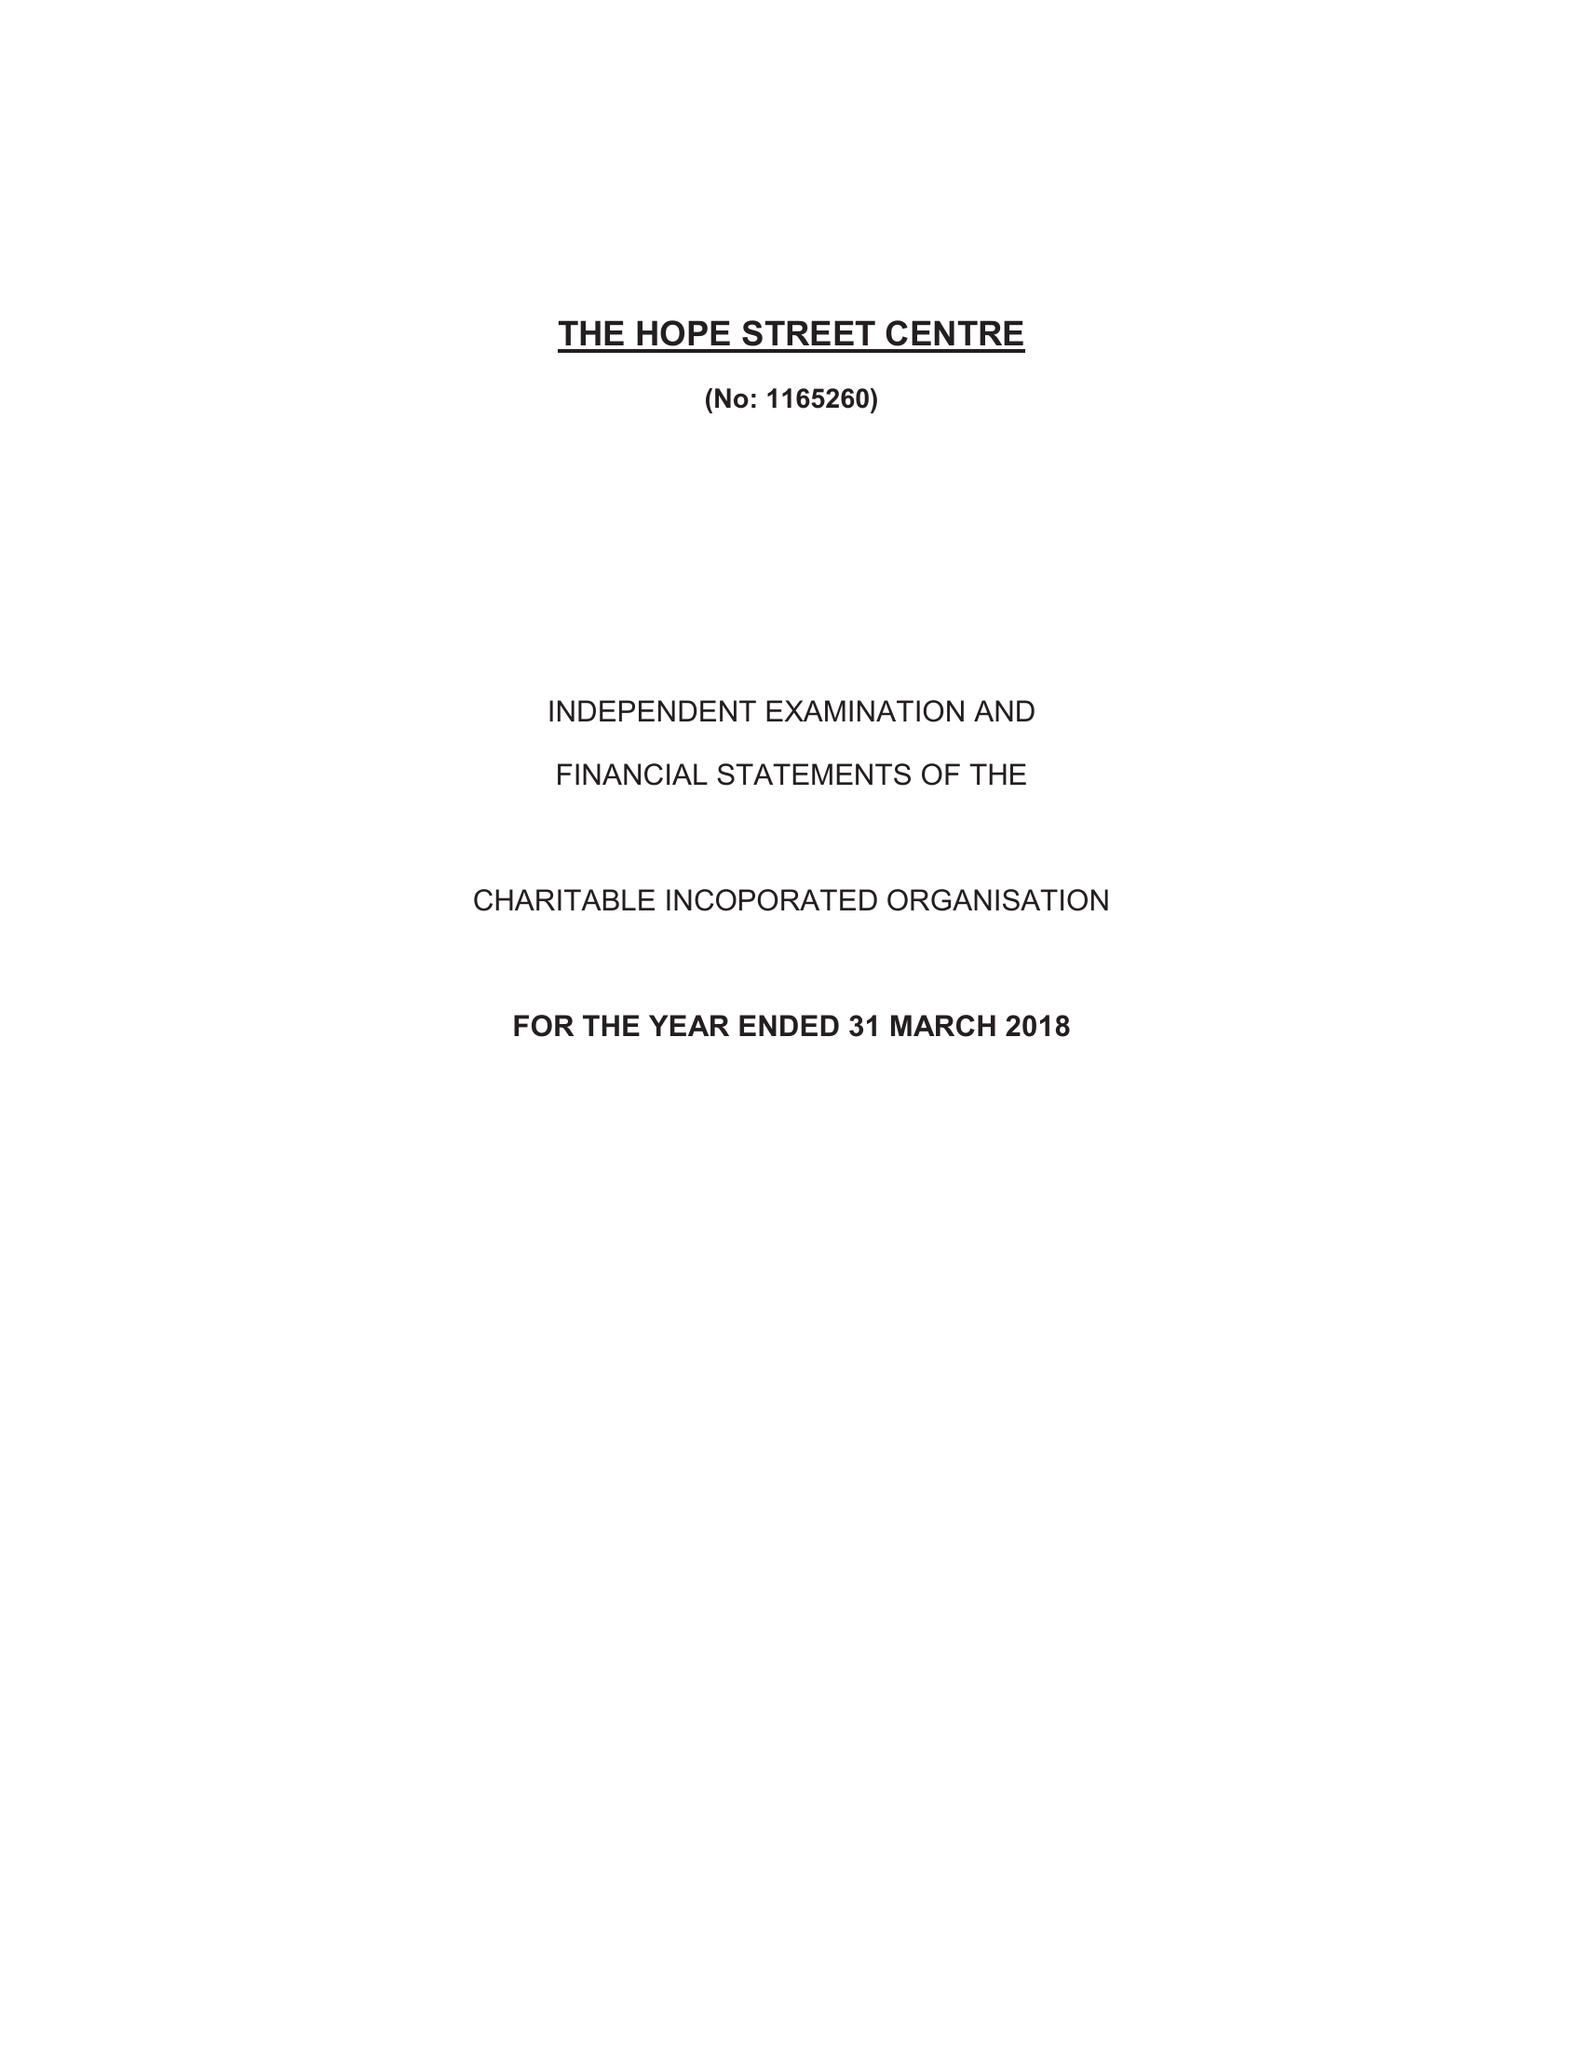What is the value for the spending_annually_in_british_pounds?
Answer the question using a single word or phrase. 85734.00 